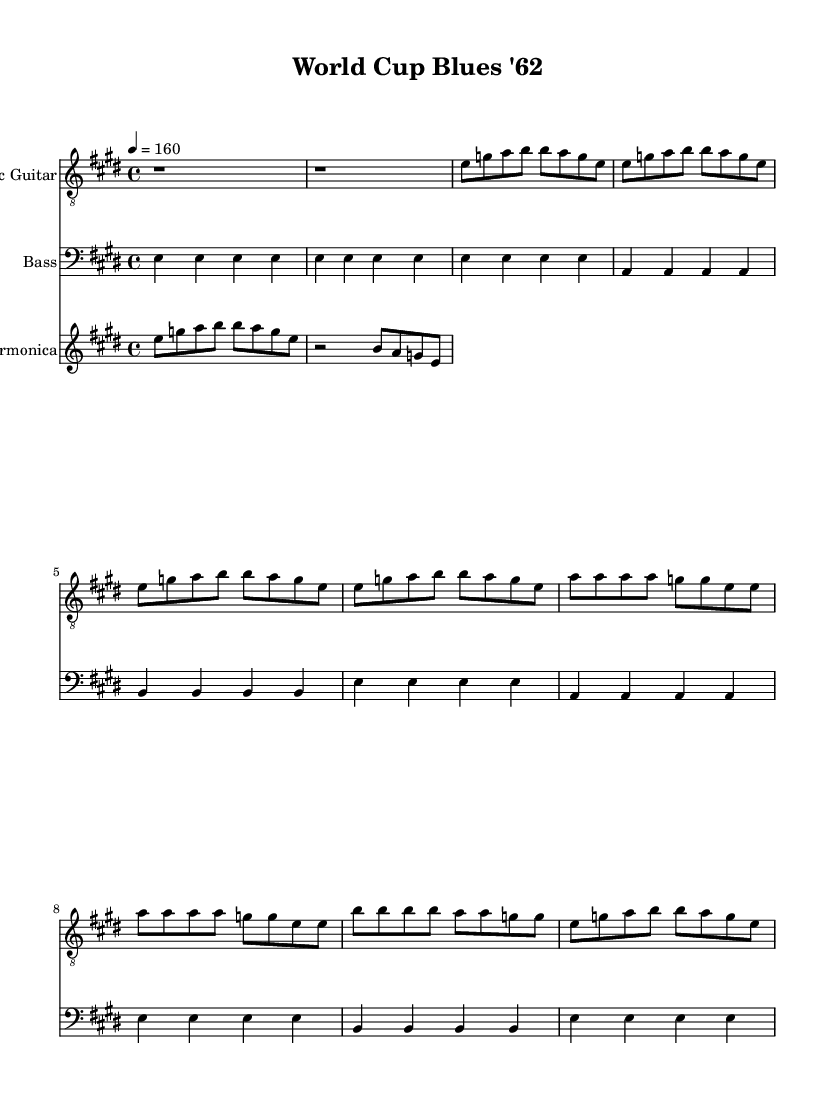What is the key signature of this music? The key signature is E major, indicated by four sharps in the key signature at the beginning of the staff.
Answer: E major What is the time signature of this piece? The time signature is 4/4, which means there are four beats in each measure, as shown in the beginning of the score.
Answer: 4/4 What is the tempo marking of this music? The tempo marking is "4 = 160", indicating that there are 160 beats per minute and each quarter note gets one beat.
Answer: 160 How many measures are in the Verse section? The Verse section consists of four measures, where each line of music for the Verse part has two measures. This can be counted directly from the portion labeled as "Verse."
Answer: 4 What is the primary instrument in this score? The primary instrument in this score is the Electric Guitar, as it is written first in the score and has a specifically named staff for it.
Answer: Electric Guitar How many different instruments are featured in this sheet music? There are three different instruments featured: Electric Guitar, Bass, and Harmonica. Each has its own staff in the score layout.
Answer: 3 What is the pattern of the bass guitar during the Intro? The pattern of the bass guitar during the Intro is simple: it plays the note E repeatedly for four beats, as indicated in the designated measures for the Intro.
Answer: E 